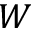Convert formula to latex. <formula><loc_0><loc_0><loc_500><loc_500>W</formula> 